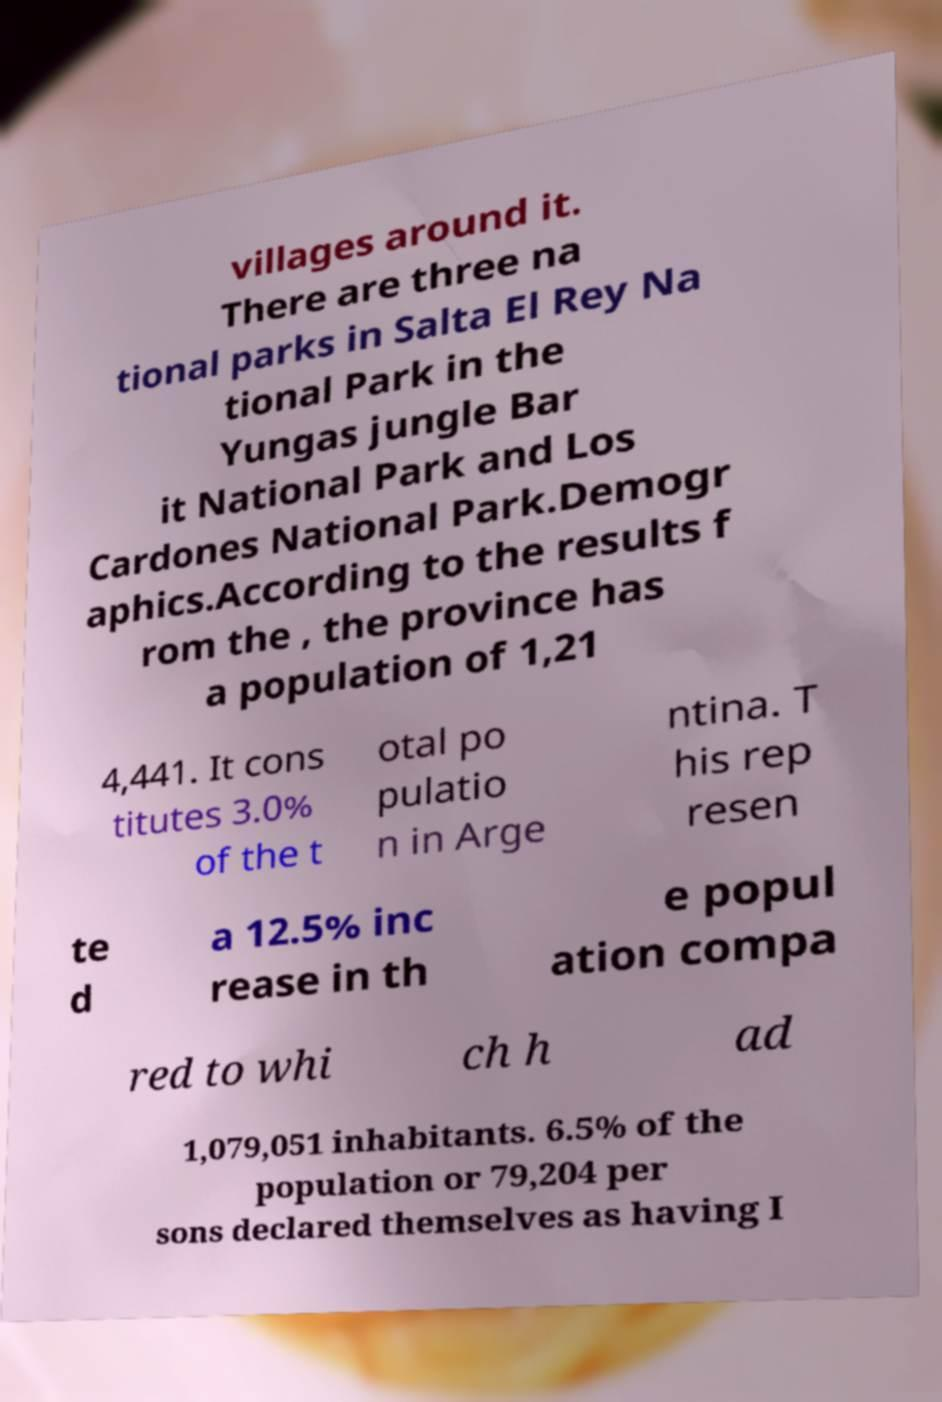Can you accurately transcribe the text from the provided image for me? villages around it. There are three na tional parks in Salta El Rey Na tional Park in the Yungas jungle Bar it National Park and Los Cardones National Park.Demogr aphics.According to the results f rom the , the province has a population of 1,21 4,441. It cons titutes 3.0% of the t otal po pulatio n in Arge ntina. T his rep resen te d a 12.5% inc rease in th e popul ation compa red to whi ch h ad 1,079,051 inhabitants. 6.5% of the population or 79,204 per sons declared themselves as having I 